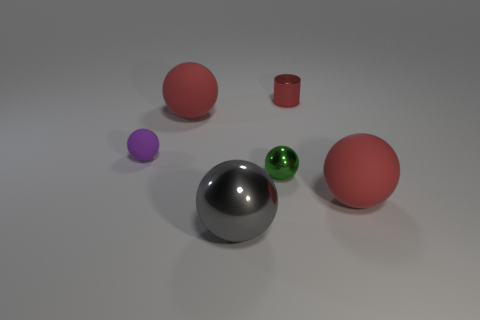Subtract all small spheres. How many spheres are left? 3 Subtract 2 spheres. How many spheres are left? 3 Subtract all gray balls. How many balls are left? 4 Subtract all purple spheres. Subtract all red cylinders. How many spheres are left? 4 Add 2 red rubber spheres. How many objects exist? 8 Subtract all spheres. How many objects are left? 1 Subtract 0 cyan balls. How many objects are left? 6 Subtract all red shiny objects. Subtract all metallic cylinders. How many objects are left? 4 Add 6 small purple rubber balls. How many small purple rubber balls are left? 7 Add 1 gray metallic things. How many gray metallic things exist? 2 